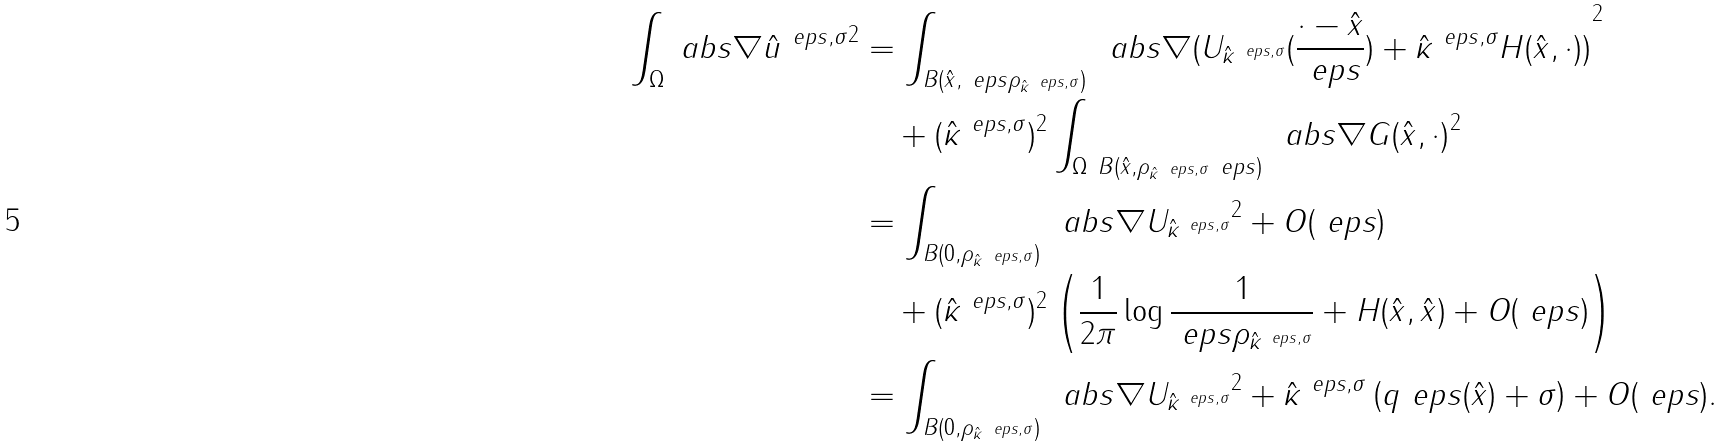Convert formula to latex. <formula><loc_0><loc_0><loc_500><loc_500>\int _ { \Omega } \ a b s { \nabla \hat { u } ^ { \ e p s , \sigma } } ^ { 2 } & = \int _ { B ( \hat { x } , \ e p s \rho _ { \hat { \kappa } ^ { \ e p s , \sigma } } ) } \, \ a b s { \nabla ( U _ { \hat { \kappa } ^ { \ e p s , \sigma } } ( \frac { \cdot - \hat { x } } { \ e p s } ) + \hat { \kappa } ^ { \ e p s , \sigma } H ( \hat { x } , \cdot ) ) } ^ { 2 } \\ & \quad + ( \hat { \kappa } ^ { \ e p s , \sigma } ) ^ { 2 } \int _ { \Omega \ B ( \hat { x } , \rho _ { \hat { \kappa } ^ { \ e p s , \sigma } } \ e p s ) } \, \ a b s { \nabla G ( \hat { x } , \cdot ) } ^ { 2 } \\ & = \int _ { B ( 0 , \rho _ { \hat { \kappa } ^ { \ e p s , \sigma } } ) } \, \ a b s { \nabla U _ { \hat { \kappa } ^ { \ e p s , \sigma } } } ^ { 2 } + O ( \ e p s ) \\ & \quad + ( \hat { \kappa } ^ { \ e p s , \sigma } ) ^ { 2 } \left ( \frac { 1 } { 2 \pi } \log \frac { 1 } { \ e p s \rho _ { \hat { \kappa } ^ { \ e p s , \sigma } } } + H ( \hat { x } , \hat { x } ) + O ( \ e p s ) \right ) \\ & = \int _ { B ( 0 , \rho _ { \hat { \kappa } ^ { \ e p s , \sigma } } ) } \, \ a b s { \nabla U _ { \hat { \kappa } ^ { \ e p s , \sigma } } } ^ { 2 } + \hat { \kappa } ^ { \ e p s , \sigma } \left ( q ^ { \ } e p s ( \hat { x } ) + \sigma \right ) + O ( \ e p s ) .</formula> 